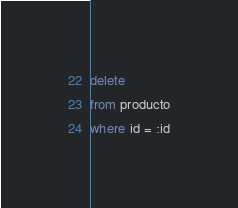<code> <loc_0><loc_0><loc_500><loc_500><_SQL_>delete 
from producto
where id = :id
</code> 